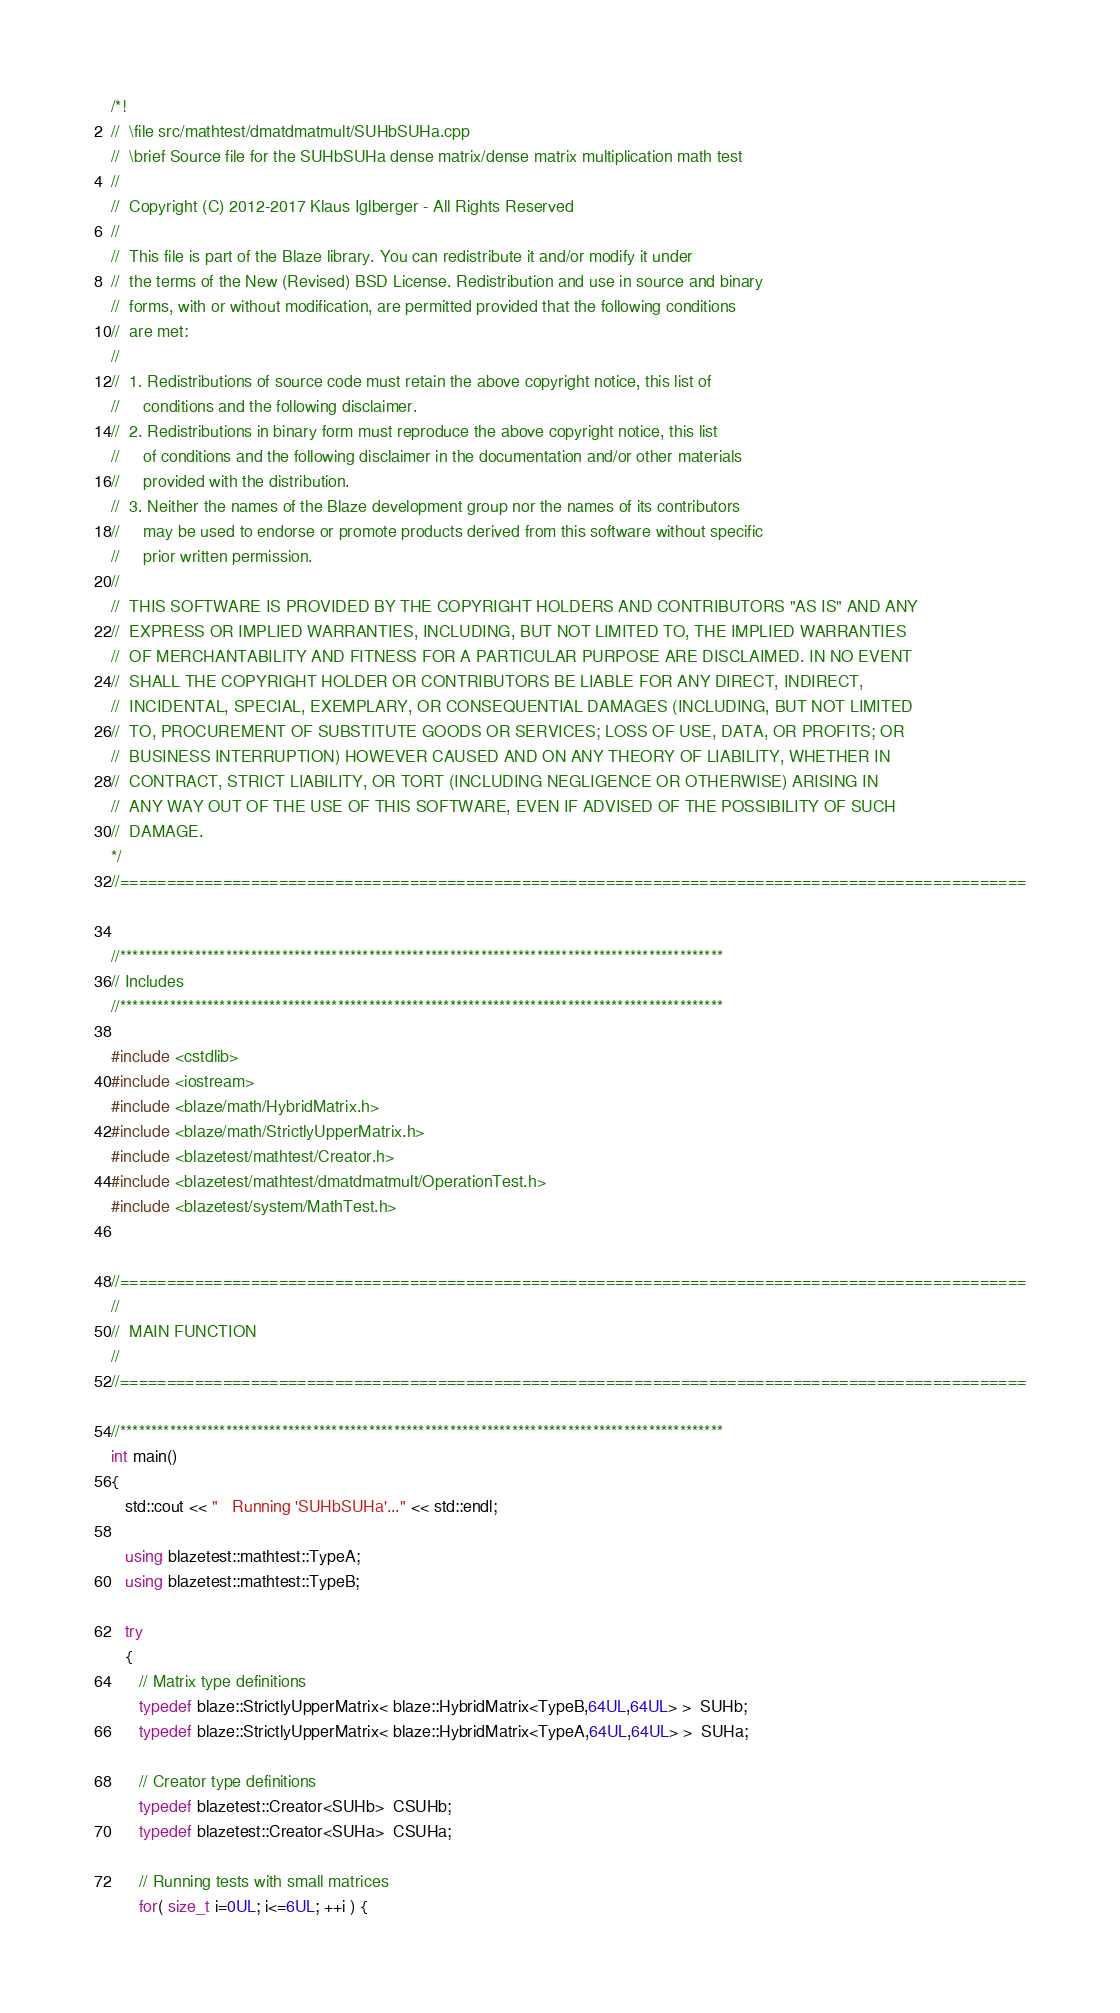<code> <loc_0><loc_0><loc_500><loc_500><_C++_>/*!
//  \file src/mathtest/dmatdmatmult/SUHbSUHa.cpp
//  \brief Source file for the SUHbSUHa dense matrix/dense matrix multiplication math test
//
//  Copyright (C) 2012-2017 Klaus Iglberger - All Rights Reserved
//
//  This file is part of the Blaze library. You can redistribute it and/or modify it under
//  the terms of the New (Revised) BSD License. Redistribution and use in source and binary
//  forms, with or without modification, are permitted provided that the following conditions
//  are met:
//
//  1. Redistributions of source code must retain the above copyright notice, this list of
//     conditions and the following disclaimer.
//  2. Redistributions in binary form must reproduce the above copyright notice, this list
//     of conditions and the following disclaimer in the documentation and/or other materials
//     provided with the distribution.
//  3. Neither the names of the Blaze development group nor the names of its contributors
//     may be used to endorse or promote products derived from this software without specific
//     prior written permission.
//
//  THIS SOFTWARE IS PROVIDED BY THE COPYRIGHT HOLDERS AND CONTRIBUTORS "AS IS" AND ANY
//  EXPRESS OR IMPLIED WARRANTIES, INCLUDING, BUT NOT LIMITED TO, THE IMPLIED WARRANTIES
//  OF MERCHANTABILITY AND FITNESS FOR A PARTICULAR PURPOSE ARE DISCLAIMED. IN NO EVENT
//  SHALL THE COPYRIGHT HOLDER OR CONTRIBUTORS BE LIABLE FOR ANY DIRECT, INDIRECT,
//  INCIDENTAL, SPECIAL, EXEMPLARY, OR CONSEQUENTIAL DAMAGES (INCLUDING, BUT NOT LIMITED
//  TO, PROCUREMENT OF SUBSTITUTE GOODS OR SERVICES; LOSS OF USE, DATA, OR PROFITS; OR
//  BUSINESS INTERRUPTION) HOWEVER CAUSED AND ON ANY THEORY OF LIABILITY, WHETHER IN
//  CONTRACT, STRICT LIABILITY, OR TORT (INCLUDING NEGLIGENCE OR OTHERWISE) ARISING IN
//  ANY WAY OUT OF THE USE OF THIS SOFTWARE, EVEN IF ADVISED OF THE POSSIBILITY OF SUCH
//  DAMAGE.
*/
//=================================================================================================


//*************************************************************************************************
// Includes
//*************************************************************************************************

#include <cstdlib>
#include <iostream>
#include <blaze/math/HybridMatrix.h>
#include <blaze/math/StrictlyUpperMatrix.h>
#include <blazetest/mathtest/Creator.h>
#include <blazetest/mathtest/dmatdmatmult/OperationTest.h>
#include <blazetest/system/MathTest.h>


//=================================================================================================
//
//  MAIN FUNCTION
//
//=================================================================================================

//*************************************************************************************************
int main()
{
   std::cout << "   Running 'SUHbSUHa'..." << std::endl;

   using blazetest::mathtest::TypeA;
   using blazetest::mathtest::TypeB;

   try
   {
      // Matrix type definitions
      typedef blaze::StrictlyUpperMatrix< blaze::HybridMatrix<TypeB,64UL,64UL> >  SUHb;
      typedef blaze::StrictlyUpperMatrix< blaze::HybridMatrix<TypeA,64UL,64UL> >  SUHa;

      // Creator type definitions
      typedef blazetest::Creator<SUHb>  CSUHb;
      typedef blazetest::Creator<SUHa>  CSUHa;

      // Running tests with small matrices
      for( size_t i=0UL; i<=6UL; ++i ) {</code> 